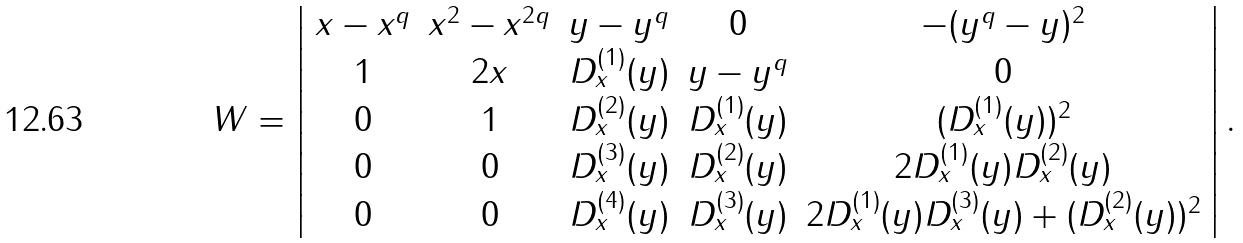Convert formula to latex. <formula><loc_0><loc_0><loc_500><loc_500>W = \left | \begin{array} { c c c c c } x - x ^ { q } & x ^ { 2 } - x ^ { 2 q } & y - y ^ { q } & 0 & - ( y ^ { q } - y ) ^ { 2 } \\ 1 & 2 x & D _ { x } ^ { ( 1 ) } ( y ) & y - y ^ { q } & 0 \\ 0 & 1 & D _ { x } ^ { ( 2 ) } ( y ) & D _ { x } ^ { ( 1 ) } ( y ) & ( D _ { x } ^ { ( 1 ) } ( y ) ) ^ { 2 } \\ 0 & 0 & D _ { x } ^ { ( 3 ) } ( y ) & D _ { x } ^ { ( 2 ) } ( y ) & 2 D _ { x } ^ { ( 1 ) } ( y ) D _ { x } ^ { ( 2 ) } ( y ) \\ 0 & 0 & D _ { x } ^ { ( 4 ) } ( y ) & D _ { x } ^ { ( 3 ) } ( y ) & 2 D _ { x } ^ { ( 1 ) } ( y ) D _ { x } ^ { ( 3 ) } ( y ) + ( D _ { x } ^ { ( 2 ) } ( y ) ) ^ { 2 } \end{array} \right | .</formula> 